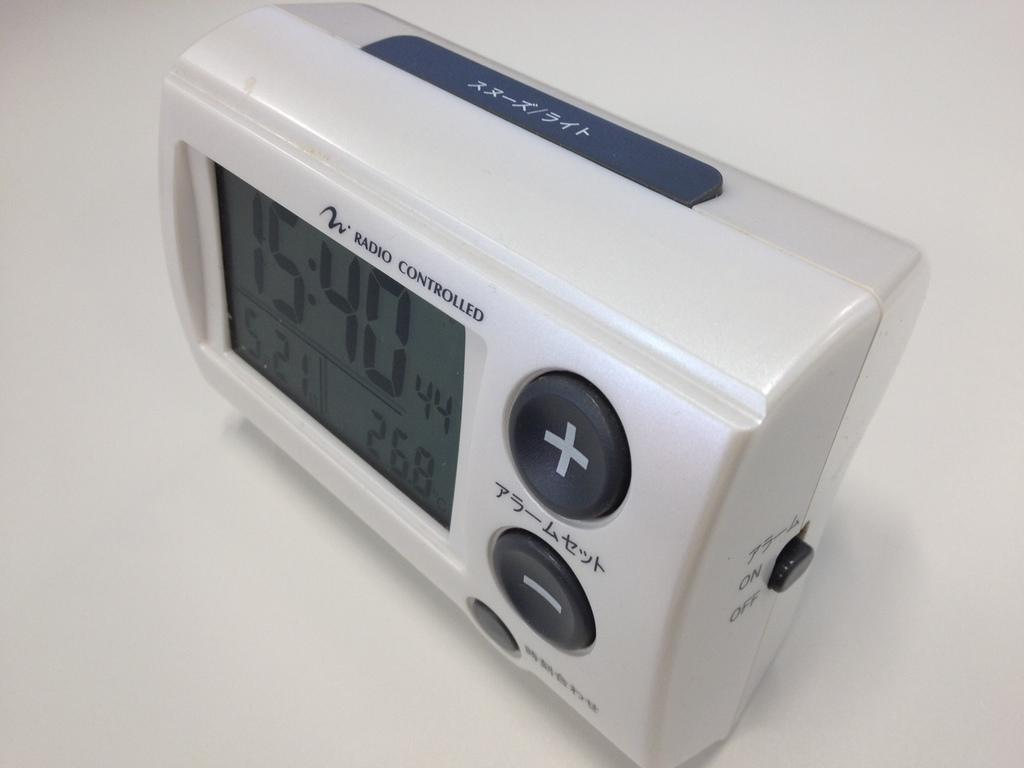Provide a one-sentence caption for the provided image. A which digital clock which says Radio Controlled on the front of the clock. 